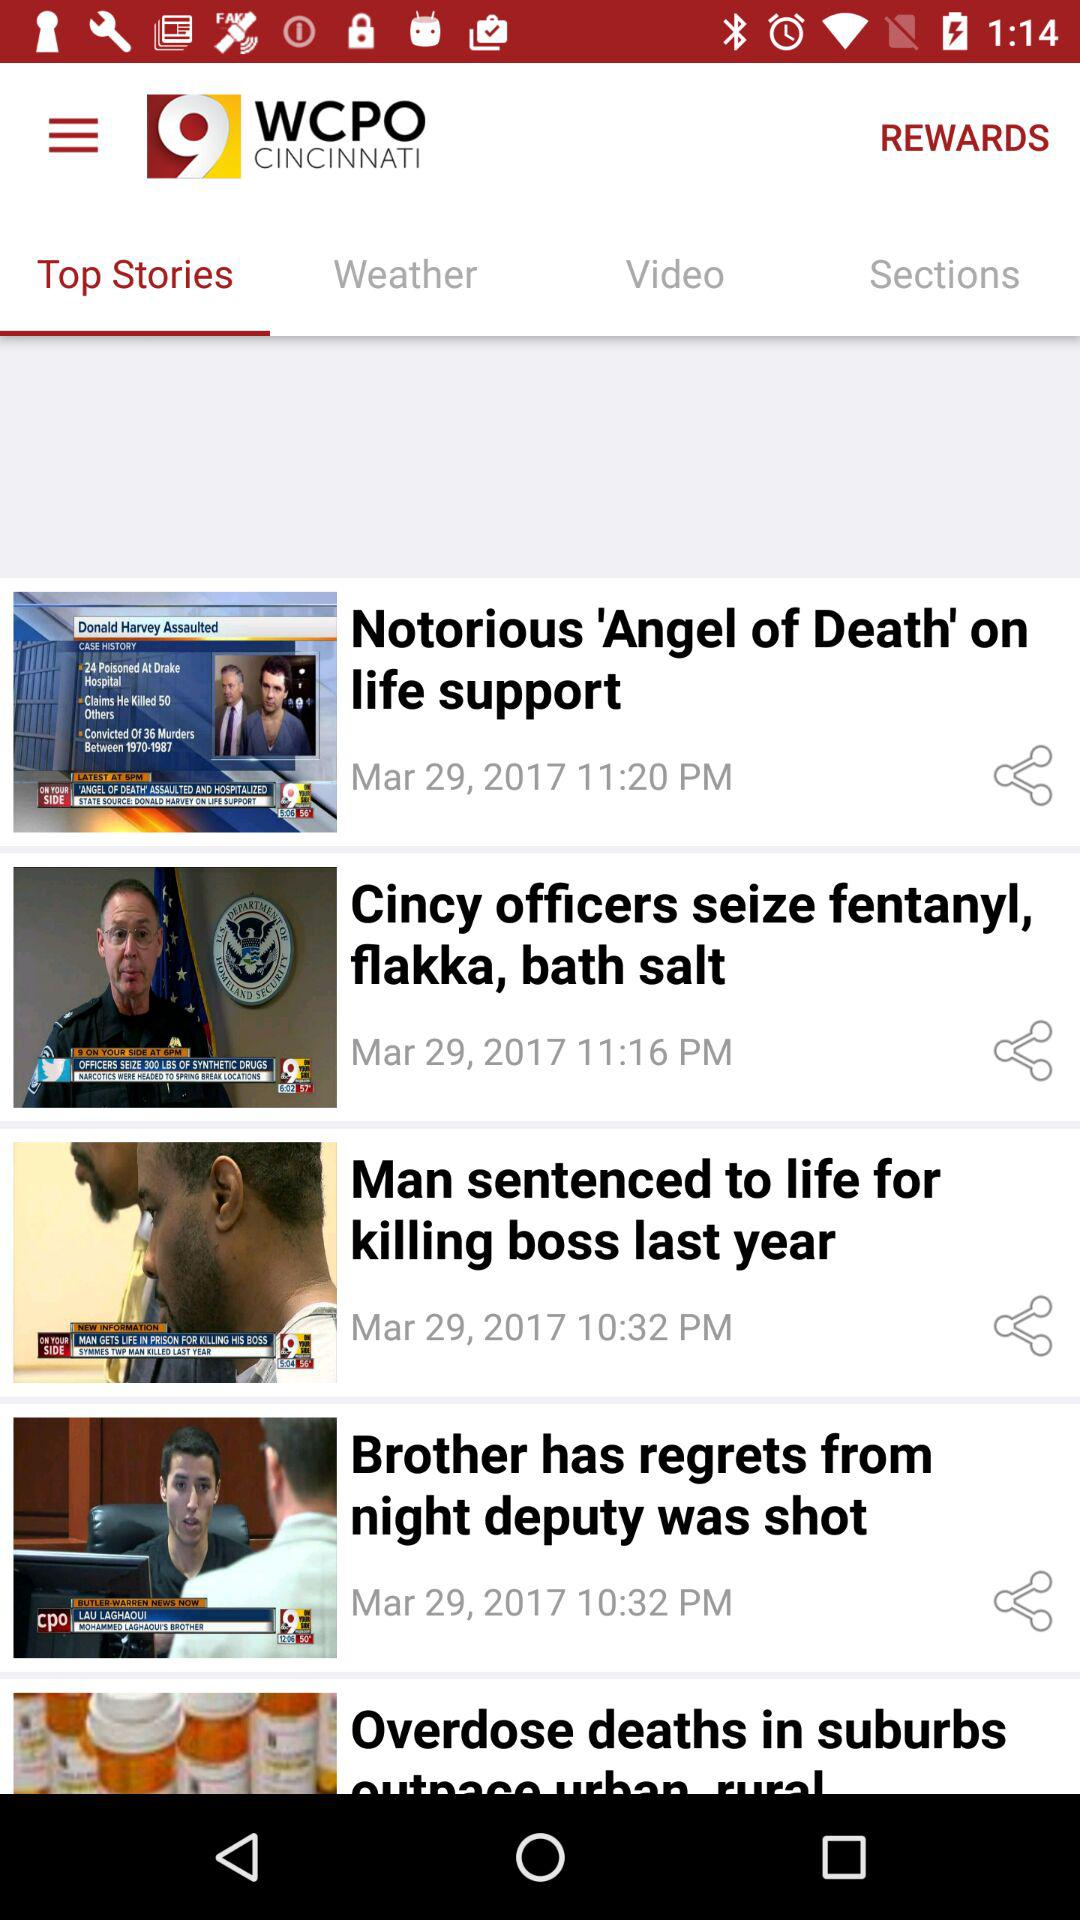What is the story posted at 11:16 pm on March 29, 2017? The story is "Cincy officers seize fentanyl, flakka, bath salt". 